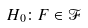Convert formula to latex. <formula><loc_0><loc_0><loc_500><loc_500>H _ { 0 } \colon F \in \mathcal { F }</formula> 